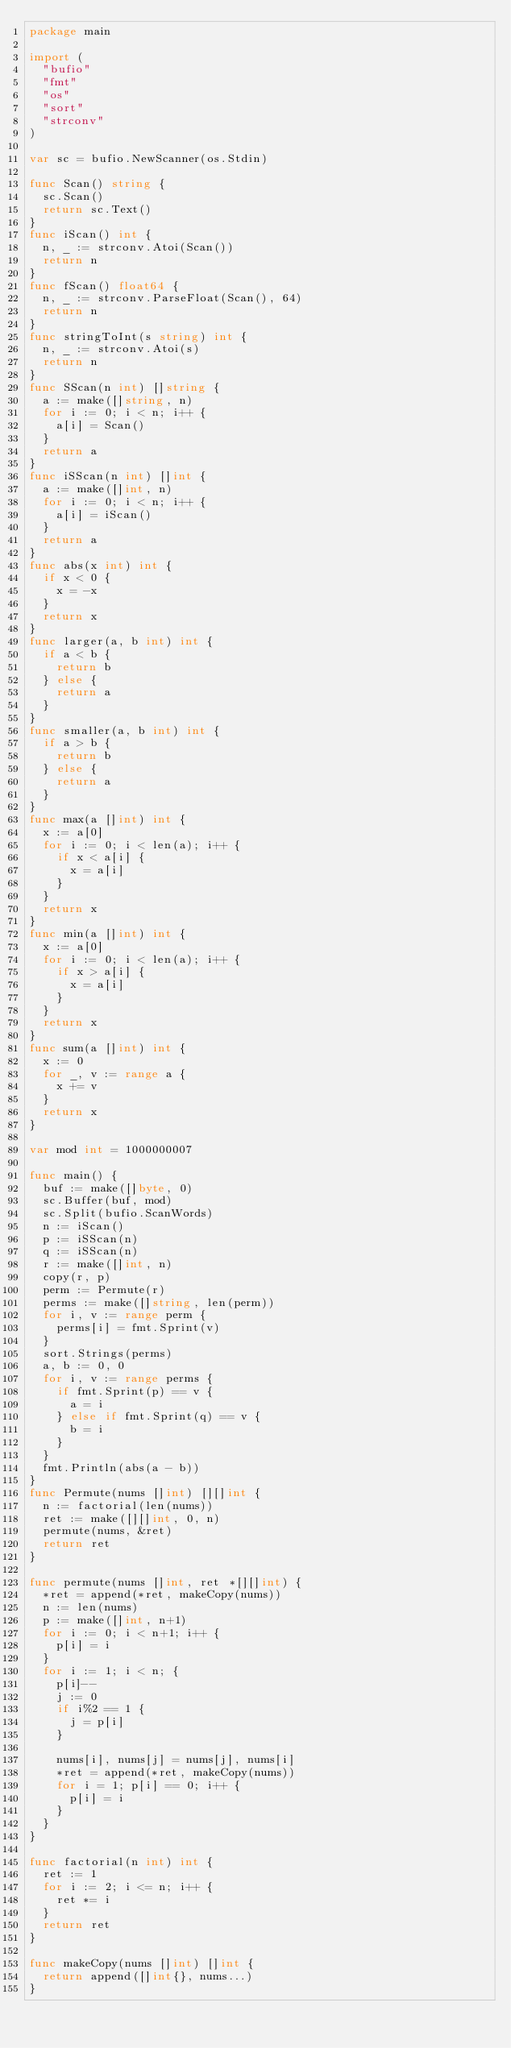Convert code to text. <code><loc_0><loc_0><loc_500><loc_500><_Go_>package main

import (
	"bufio"
	"fmt"
	"os"
	"sort"
	"strconv"
)

var sc = bufio.NewScanner(os.Stdin)

func Scan() string {
	sc.Scan()
	return sc.Text()
}
func iScan() int {
	n, _ := strconv.Atoi(Scan())
	return n
}
func fScan() float64 {
	n, _ := strconv.ParseFloat(Scan(), 64)
	return n
}
func stringToInt(s string) int {
	n, _ := strconv.Atoi(s)
	return n
}
func SScan(n int) []string {
	a := make([]string, n)
	for i := 0; i < n; i++ {
		a[i] = Scan()
	}
	return a
}
func iSScan(n int) []int {
	a := make([]int, n)
	for i := 0; i < n; i++ {
		a[i] = iScan()
	}
	return a
}
func abs(x int) int {
	if x < 0 {
		x = -x
	}
	return x
}
func larger(a, b int) int {
	if a < b {
		return b
	} else {
		return a
	}
}
func smaller(a, b int) int {
	if a > b {
		return b
	} else {
		return a
	}
}
func max(a []int) int {
	x := a[0]
	for i := 0; i < len(a); i++ {
		if x < a[i] {
			x = a[i]
		}
	}
	return x
}
func min(a []int) int {
	x := a[0]
	for i := 0; i < len(a); i++ {
		if x > a[i] {
			x = a[i]
		}
	}
	return x
}
func sum(a []int) int {
	x := 0
	for _, v := range a {
		x += v
	}
	return x
}

var mod int = 1000000007

func main() {
	buf := make([]byte, 0)
	sc.Buffer(buf, mod)
	sc.Split(bufio.ScanWords)
	n := iScan()
	p := iSScan(n)
	q := iSScan(n)
	r := make([]int, n)
	copy(r, p)
	perm := Permute(r)
	perms := make([]string, len(perm))
	for i, v := range perm {
		perms[i] = fmt.Sprint(v)
	}
	sort.Strings(perms)
	a, b := 0, 0
	for i, v := range perms {
		if fmt.Sprint(p) == v {
			a = i
		} else if fmt.Sprint(q) == v {
			b = i
		}
	}
	fmt.Println(abs(a - b))
}
func Permute(nums []int) [][]int {
	n := factorial(len(nums))
	ret := make([][]int, 0, n)
	permute(nums, &ret)
	return ret
}

func permute(nums []int, ret *[][]int) {
	*ret = append(*ret, makeCopy(nums))
	n := len(nums)
	p := make([]int, n+1)
	for i := 0; i < n+1; i++ {
		p[i] = i
	}
	for i := 1; i < n; {
		p[i]--
		j := 0
		if i%2 == 1 {
			j = p[i]
		}

		nums[i], nums[j] = nums[j], nums[i]
		*ret = append(*ret, makeCopy(nums))
		for i = 1; p[i] == 0; i++ {
			p[i] = i
		}
	}
}

func factorial(n int) int {
	ret := 1
	for i := 2; i <= n; i++ {
		ret *= i
	}
	return ret
}

func makeCopy(nums []int) []int {
	return append([]int{}, nums...)
}
</code> 